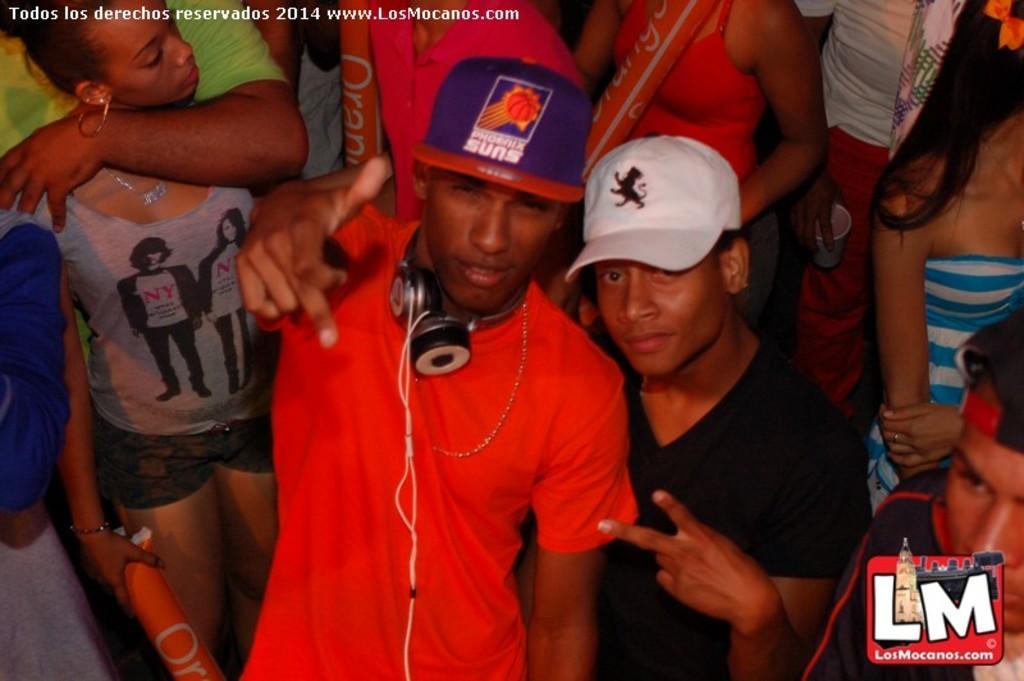Please provide a concise description of this image. In this image we can see few people standing and a person is wearing headphone on his neck and few people holding objects in their hands and a person is holding a cup. 